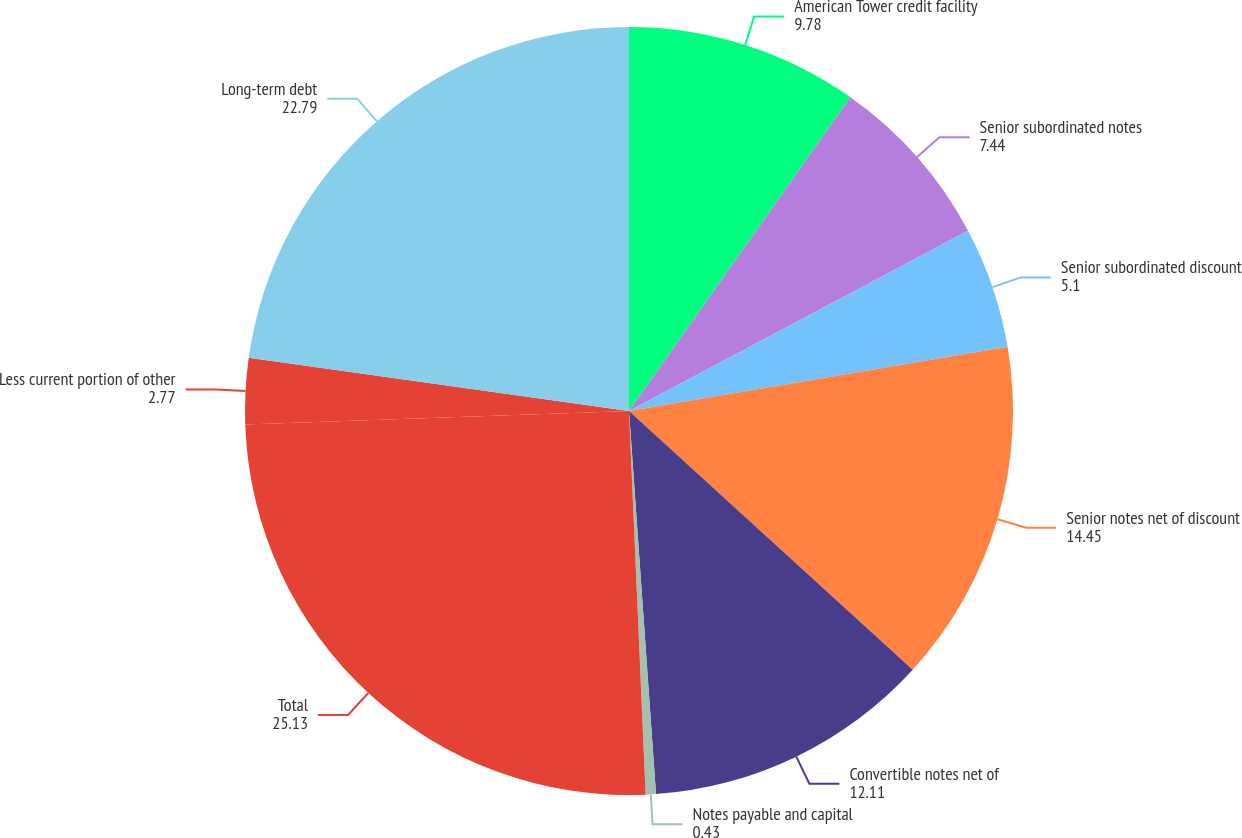Convert chart. <chart><loc_0><loc_0><loc_500><loc_500><pie_chart><fcel>American Tower credit facility<fcel>Senior subordinated notes<fcel>Senior subordinated discount<fcel>Senior notes net of discount<fcel>Convertible notes net of<fcel>Notes payable and capital<fcel>Total<fcel>Less current portion of other<fcel>Long-term debt<nl><fcel>9.78%<fcel>7.44%<fcel>5.1%<fcel>14.45%<fcel>12.11%<fcel>0.43%<fcel>25.13%<fcel>2.77%<fcel>22.79%<nl></chart> 